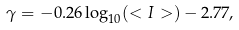<formula> <loc_0><loc_0><loc_500><loc_500>\gamma = - 0 . 2 6 \log _ { 1 0 } ( < I > ) - 2 . 7 7 ,</formula> 